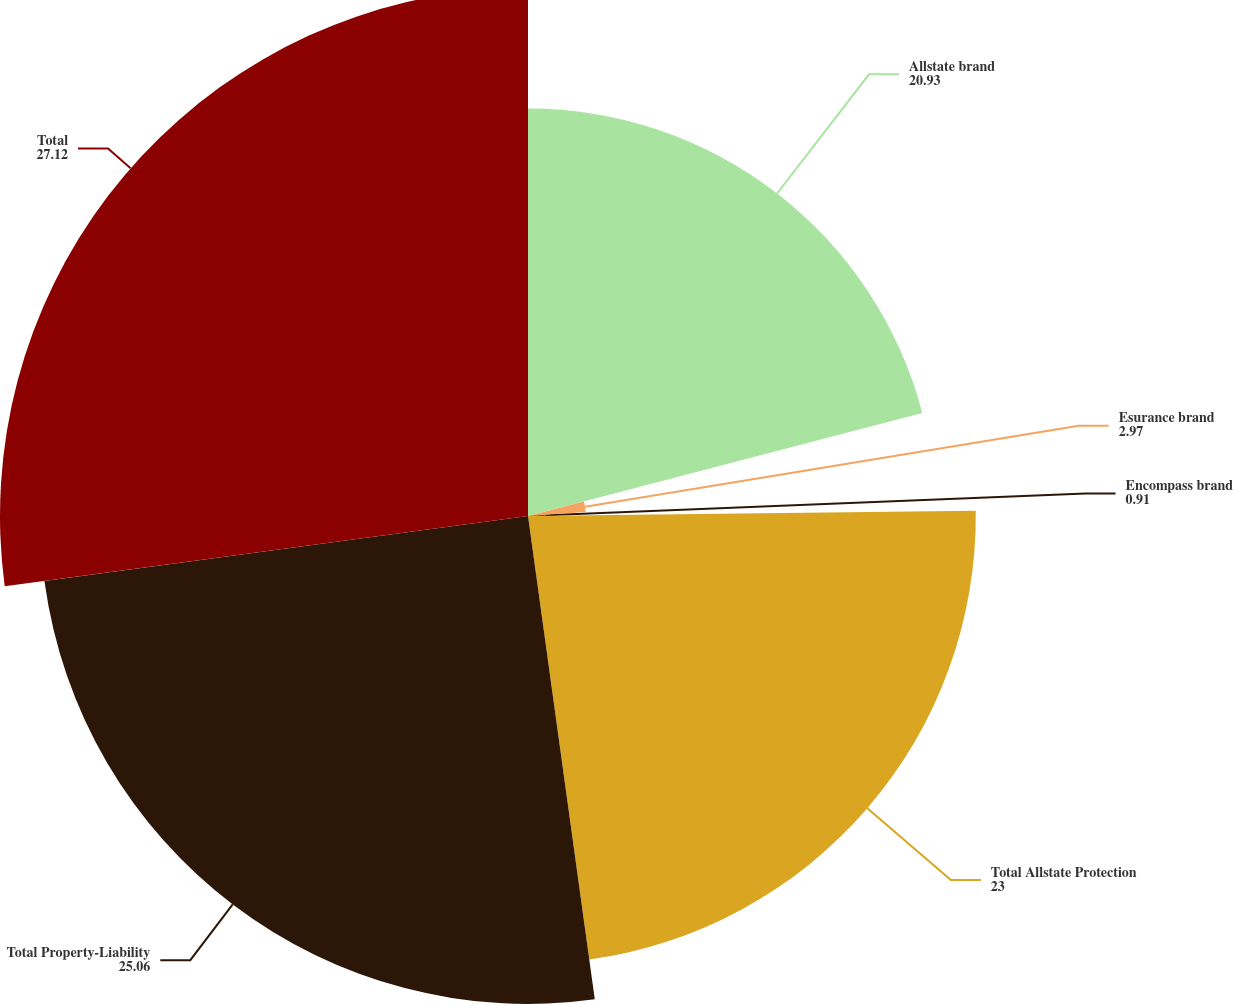Convert chart to OTSL. <chart><loc_0><loc_0><loc_500><loc_500><pie_chart><fcel>Allstate brand<fcel>Esurance brand<fcel>Encompass brand<fcel>Total Allstate Protection<fcel>Total Property-Liability<fcel>Total<nl><fcel>20.93%<fcel>2.97%<fcel>0.91%<fcel>23.0%<fcel>25.06%<fcel>27.12%<nl></chart> 